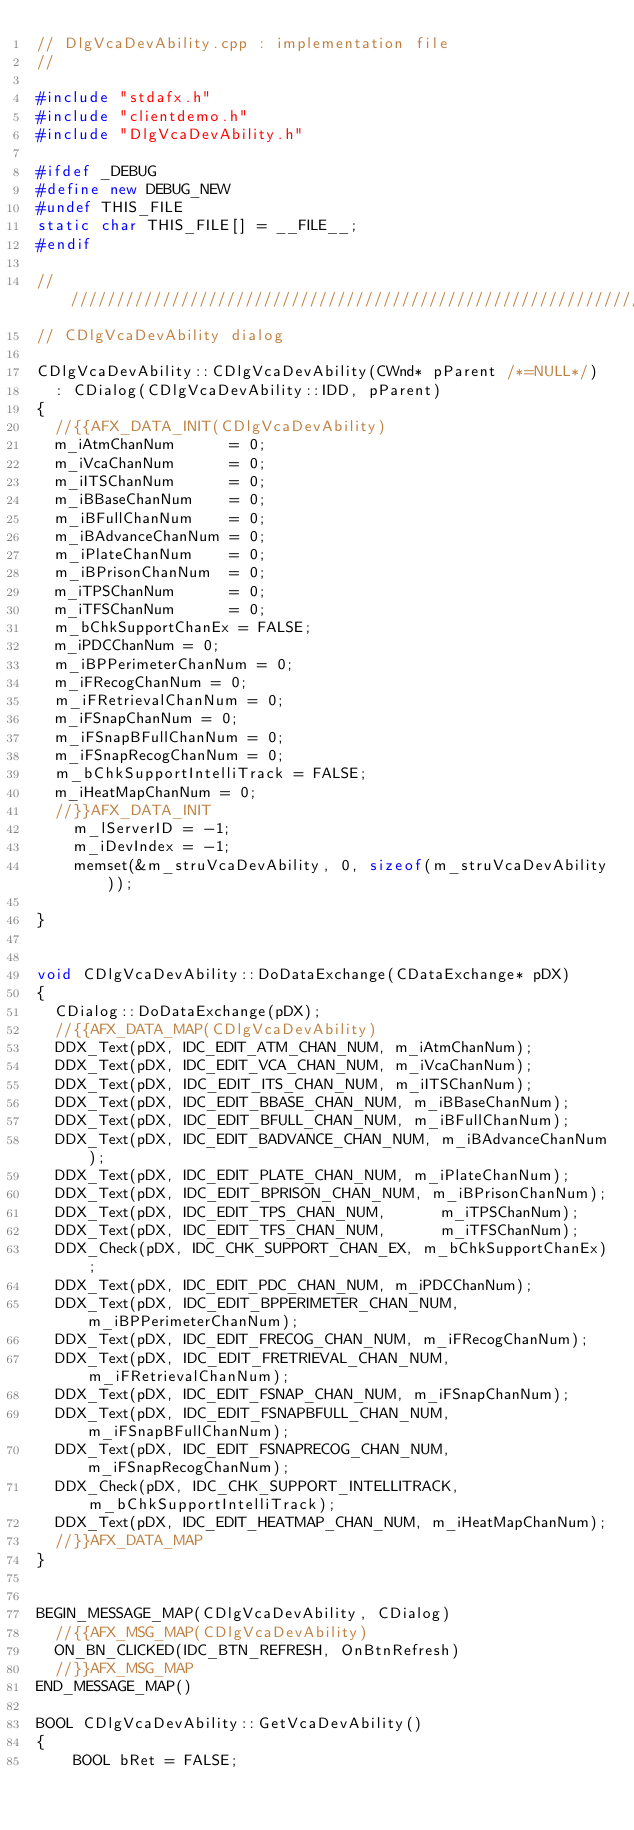Convert code to text. <code><loc_0><loc_0><loc_500><loc_500><_C++_>// DlgVcaDevAbility.cpp : implementation file
//

#include "stdafx.h"
#include "clientdemo.h"
#include "DlgVcaDevAbility.h"

#ifdef _DEBUG
#define new DEBUG_NEW
#undef THIS_FILE
static char THIS_FILE[] = __FILE__;
#endif

/////////////////////////////////////////////////////////////////////////////
// CDlgVcaDevAbility dialog

CDlgVcaDevAbility::CDlgVcaDevAbility(CWnd* pParent /*=NULL*/)
	: CDialog(CDlgVcaDevAbility::IDD, pParent)
{
	//{{AFX_DATA_INIT(CDlgVcaDevAbility)
	m_iAtmChanNum      = 0;
	m_iVcaChanNum      = 0;
	m_iITSChanNum      = 0;
	m_iBBaseChanNum    = 0;
	m_iBFullChanNum    = 0;
	m_iBAdvanceChanNum = 0;
	m_iPlateChanNum    = 0;
	m_iBPrisonChanNum  = 0;
	m_iTPSChanNum      = 0;
	m_iTFSChanNum      = 0;
	m_bChkSupportChanEx = FALSE;
	m_iPDCChanNum = 0;
	m_iBPPerimeterChanNum = 0;
	m_iFRecogChanNum = 0;
	m_iFRetrievalChanNum = 0;
	m_iFSnapChanNum = 0;
	m_iFSnapBFullChanNum = 0;
	m_iFSnapRecogChanNum = 0;
	m_bChkSupportIntelliTrack = FALSE;
	m_iHeatMapChanNum = 0;
	//}}AFX_DATA_INIT
    m_lServerID = -1;
    m_iDevIndex = -1;
    memset(&m_struVcaDevAbility, 0, sizeof(m_struVcaDevAbility));

}


void CDlgVcaDevAbility::DoDataExchange(CDataExchange* pDX)
{
	CDialog::DoDataExchange(pDX);
	//{{AFX_DATA_MAP(CDlgVcaDevAbility)
	DDX_Text(pDX, IDC_EDIT_ATM_CHAN_NUM, m_iAtmChanNum);
	DDX_Text(pDX, IDC_EDIT_VCA_CHAN_NUM, m_iVcaChanNum);
	DDX_Text(pDX, IDC_EDIT_ITS_CHAN_NUM, m_iITSChanNum);
	DDX_Text(pDX, IDC_EDIT_BBASE_CHAN_NUM, m_iBBaseChanNum);
	DDX_Text(pDX, IDC_EDIT_BFULL_CHAN_NUM, m_iBFullChanNum);
	DDX_Text(pDX, IDC_EDIT_BADVANCE_CHAN_NUM, m_iBAdvanceChanNum);
	DDX_Text(pDX, IDC_EDIT_PLATE_CHAN_NUM, m_iPlateChanNum);
	DDX_Text(pDX, IDC_EDIT_BPRISON_CHAN_NUM, m_iBPrisonChanNum);
	DDX_Text(pDX, IDC_EDIT_TPS_CHAN_NUM,      m_iTPSChanNum);
	DDX_Text(pDX, IDC_EDIT_TFS_CHAN_NUM,      m_iTFSChanNum);
	DDX_Check(pDX, IDC_CHK_SUPPORT_CHAN_EX, m_bChkSupportChanEx);
	DDX_Text(pDX, IDC_EDIT_PDC_CHAN_NUM, m_iPDCChanNum);
	DDX_Text(pDX, IDC_EDIT_BPPERIMETER_CHAN_NUM, m_iBPPerimeterChanNum);
	DDX_Text(pDX, IDC_EDIT_FRECOG_CHAN_NUM, m_iFRecogChanNum);
	DDX_Text(pDX, IDC_EDIT_FRETRIEVAL_CHAN_NUM, m_iFRetrievalChanNum);
	DDX_Text(pDX, IDC_EDIT_FSNAP_CHAN_NUM, m_iFSnapChanNum);
	DDX_Text(pDX, IDC_EDIT_FSNAPBFULL_CHAN_NUM, m_iFSnapBFullChanNum);
	DDX_Text(pDX, IDC_EDIT_FSNAPRECOG_CHAN_NUM, m_iFSnapRecogChanNum);
	DDX_Check(pDX, IDC_CHK_SUPPORT_INTELLITRACK, m_bChkSupportIntelliTrack);
	DDX_Text(pDX, IDC_EDIT_HEATMAP_CHAN_NUM, m_iHeatMapChanNum);
	//}}AFX_DATA_MAP
}


BEGIN_MESSAGE_MAP(CDlgVcaDevAbility, CDialog)
	//{{AFX_MSG_MAP(CDlgVcaDevAbility)
	ON_BN_CLICKED(IDC_BTN_REFRESH, OnBtnRefresh)
	//}}AFX_MSG_MAP
END_MESSAGE_MAP()

BOOL CDlgVcaDevAbility::GetVcaDevAbility()
{
    BOOL bRet = FALSE;</code> 